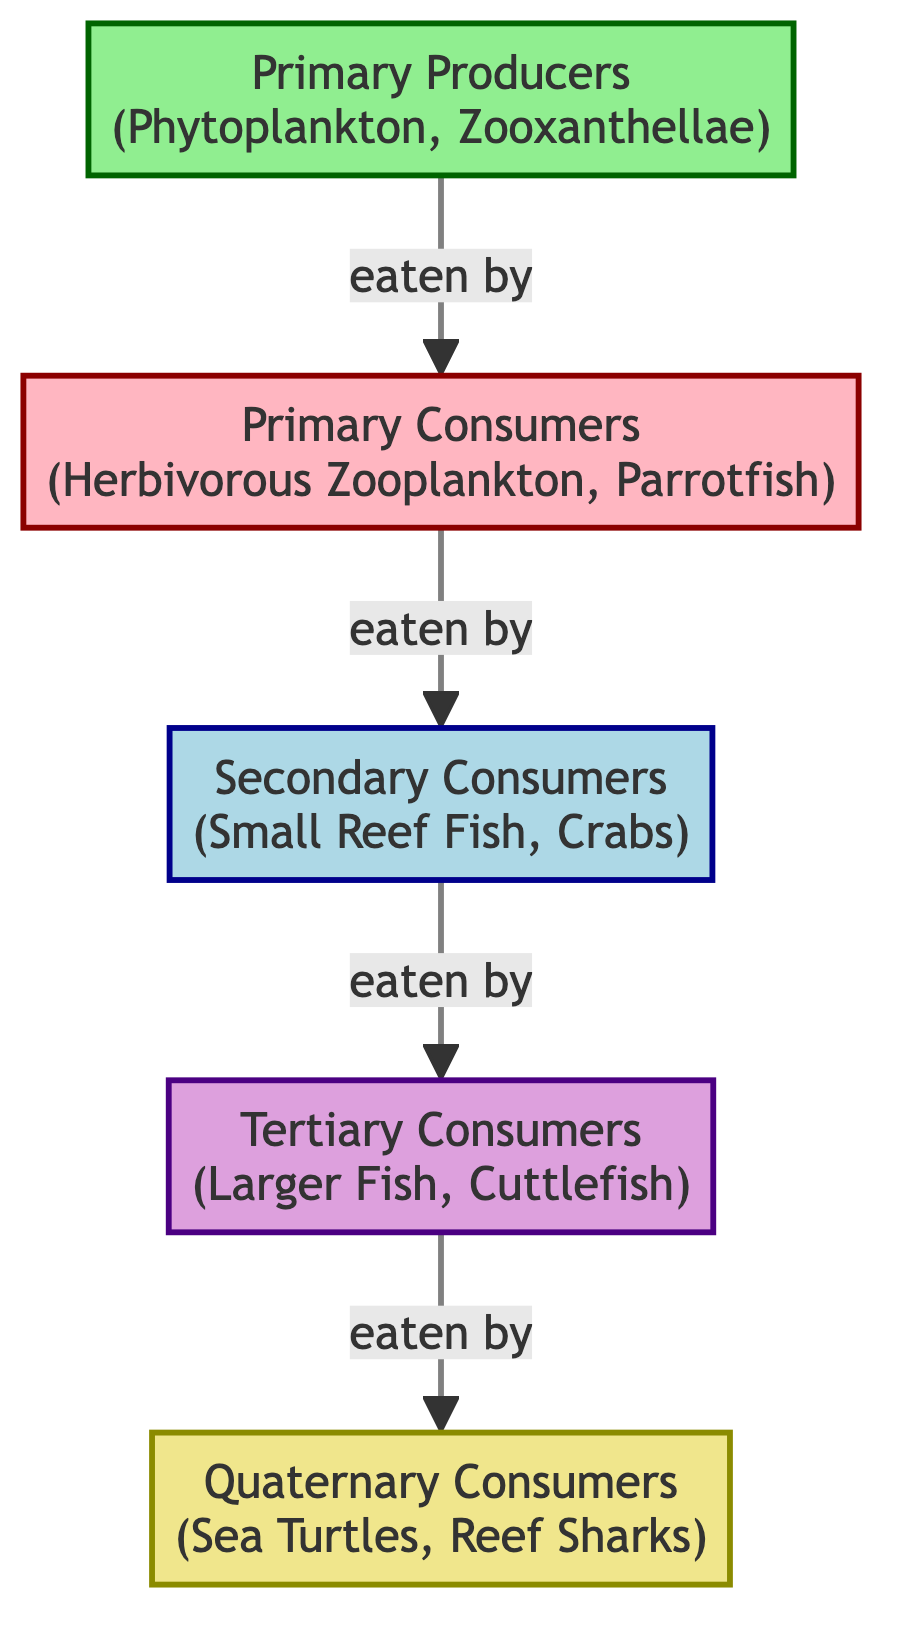What are the primary producers in this marine food chain? According to the diagram, the node labeled "Primary Producers" lists "Phytoplankton" and "Zooxanthellae" as examples of producers in the ecosystem.
Answer: Phytoplankton, Zooxanthellae Which level of consumers eats the primary consumers? The diagram indicates that the primary consumers, labeled "Herbivorous Zooplankton, Parrotfish," are eaten by the secondary consumers, which include "Small Reef Fish, Crabs." Thus, the secondary consumers are the next level that consumes the primary consumers.
Answer: Secondary Consumers How many total trophic levels are there in this food chain? By counting the nodes from the primary producers to the quaternary consumers, there are five distinct trophic levels: Primary Producers, Primary Consumers, Secondary Consumers, Tertiary Consumers, and Quaternary Consumers.
Answer: Five Who are the tertiary consumers in the food chain? The diagram specifies that the tertiary consumers are labeled as "Larger Fish, Cuttlefish." This refers to the third level of consumers that consume secondary consumers.
Answer: Larger Fish, Cuttlefish What is the relationship between primary consumers and tertiary consumers? The relationship shows a direct flow: primary consumers (Herbivorous Zooplankton, Parrotfish) are eaten by secondary consumers, which are then eaten by tertiary consumers (Larger Fish, Cuttlefish). Thus, tertiary consumers are indirectly linked to primary consumers, as they are two levels above them in the food chain.
Answer: Indirect relationship 